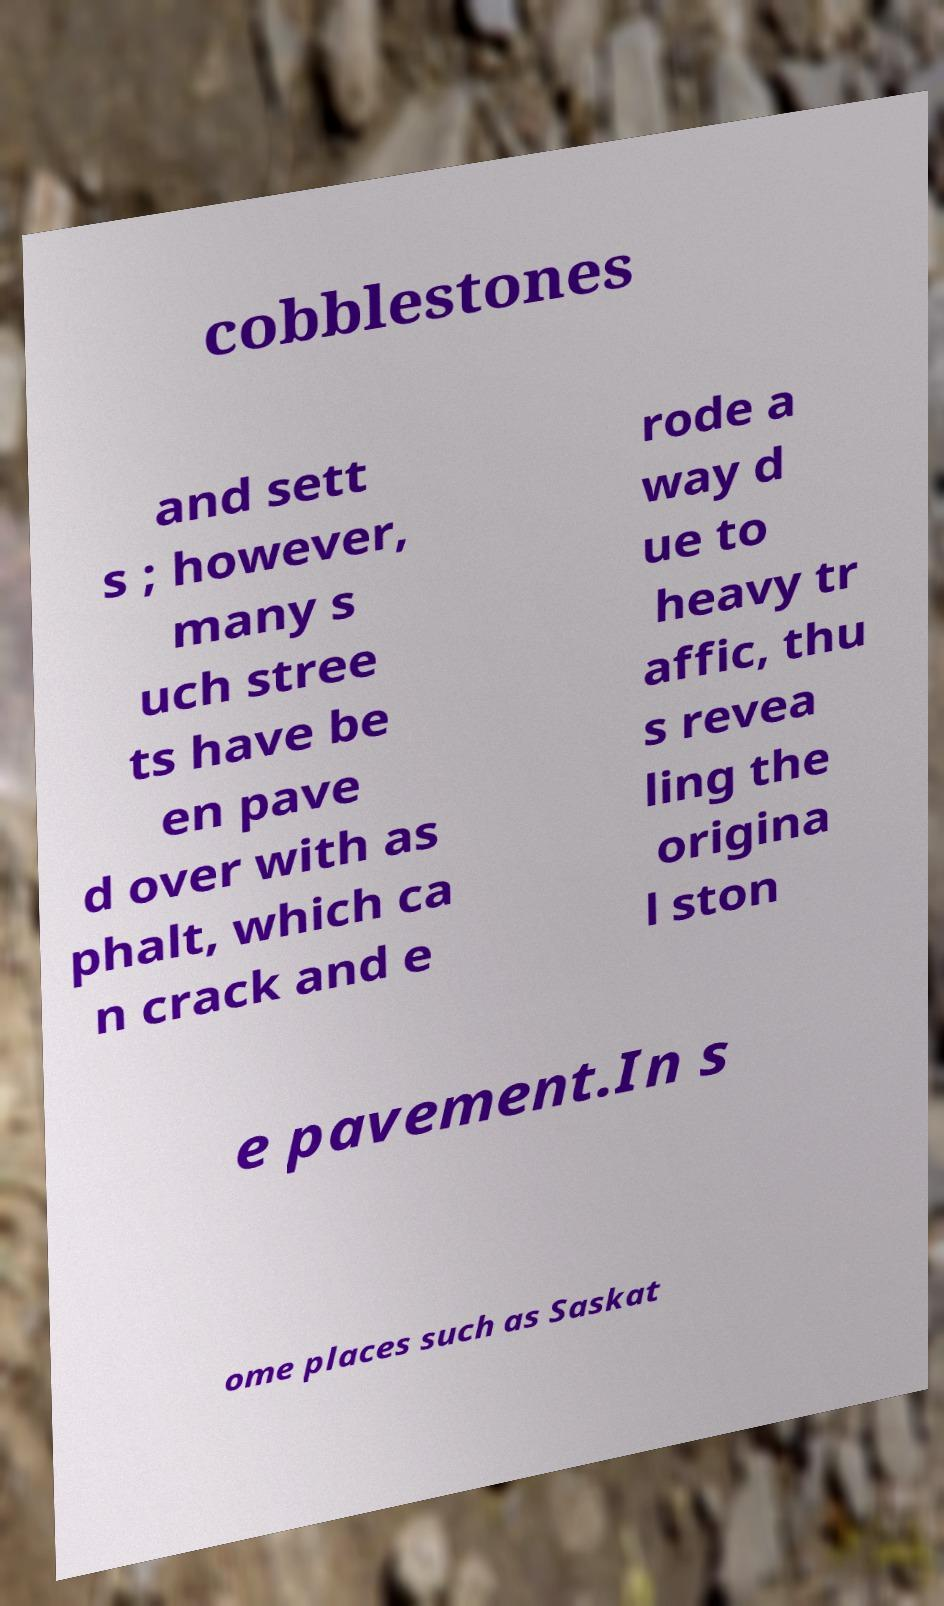I need the written content from this picture converted into text. Can you do that? cobblestones and sett s ; however, many s uch stree ts have be en pave d over with as phalt, which ca n crack and e rode a way d ue to heavy tr affic, thu s revea ling the origina l ston e pavement.In s ome places such as Saskat 